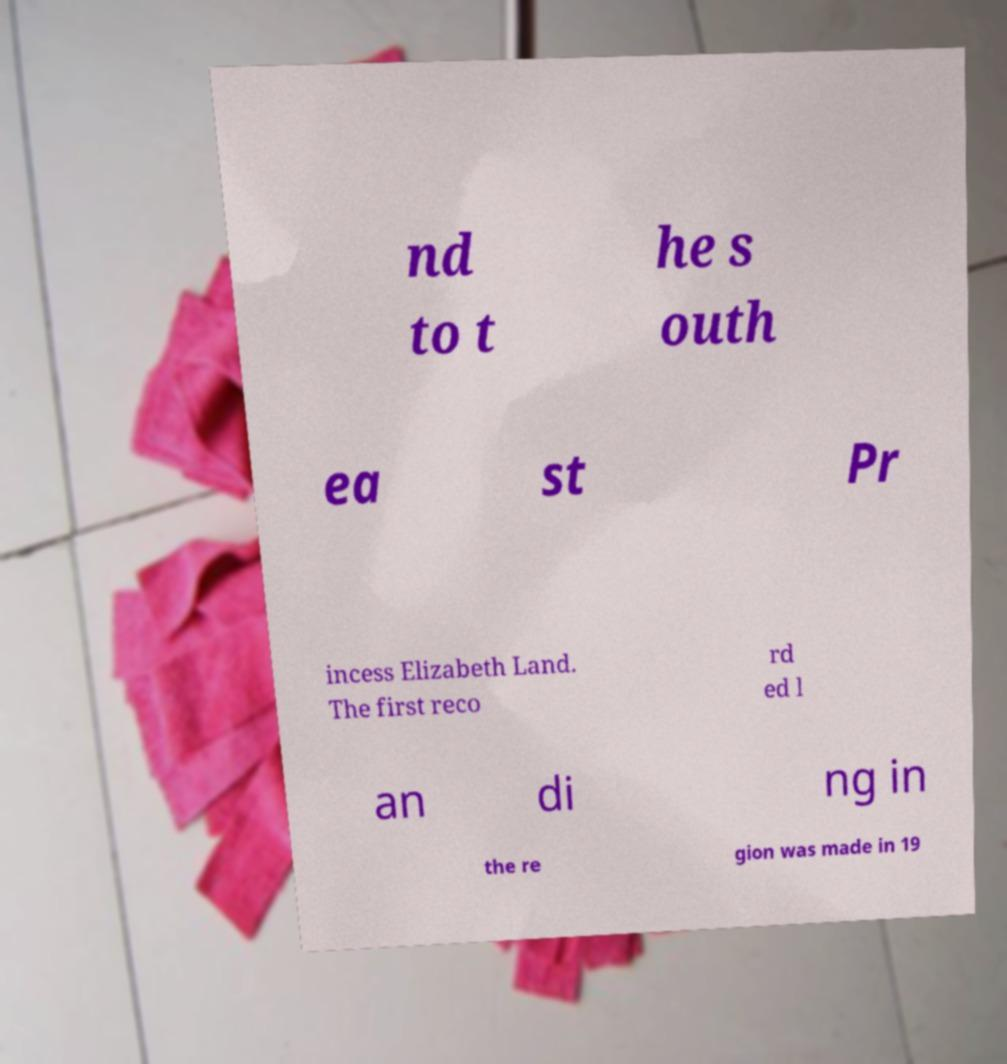I need the written content from this picture converted into text. Can you do that? nd to t he s outh ea st Pr incess Elizabeth Land. The first reco rd ed l an di ng in the re gion was made in 19 